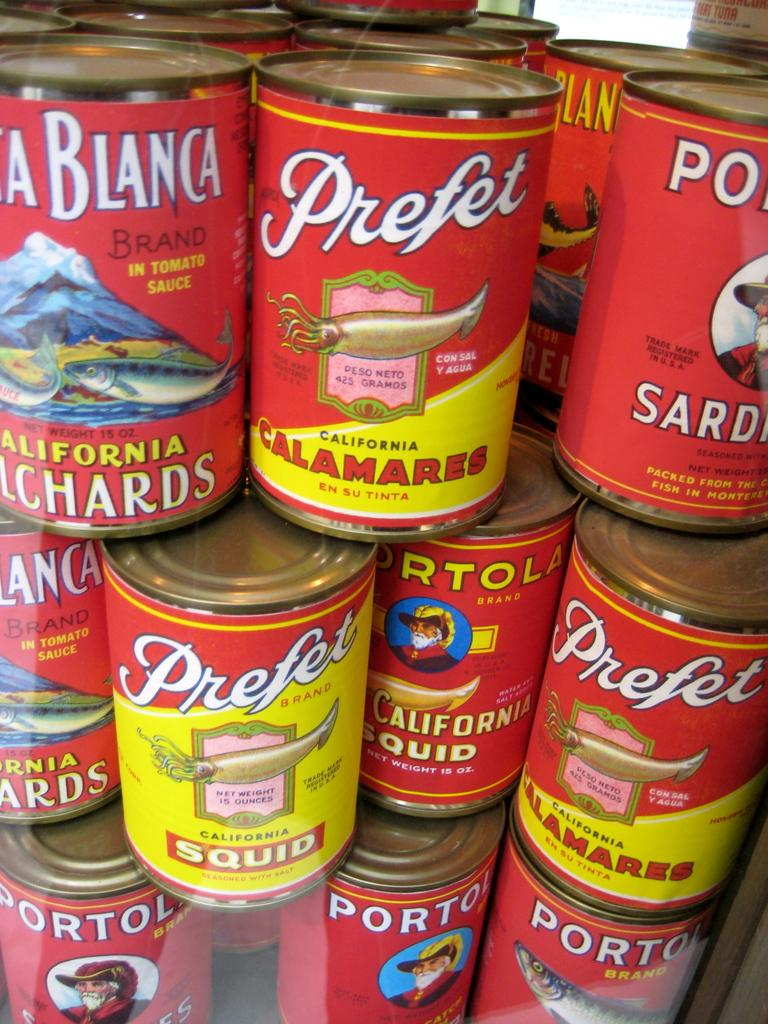<image>
Write a terse but informative summary of the picture. Lots of cans of seafood are stacked up that include squid. 